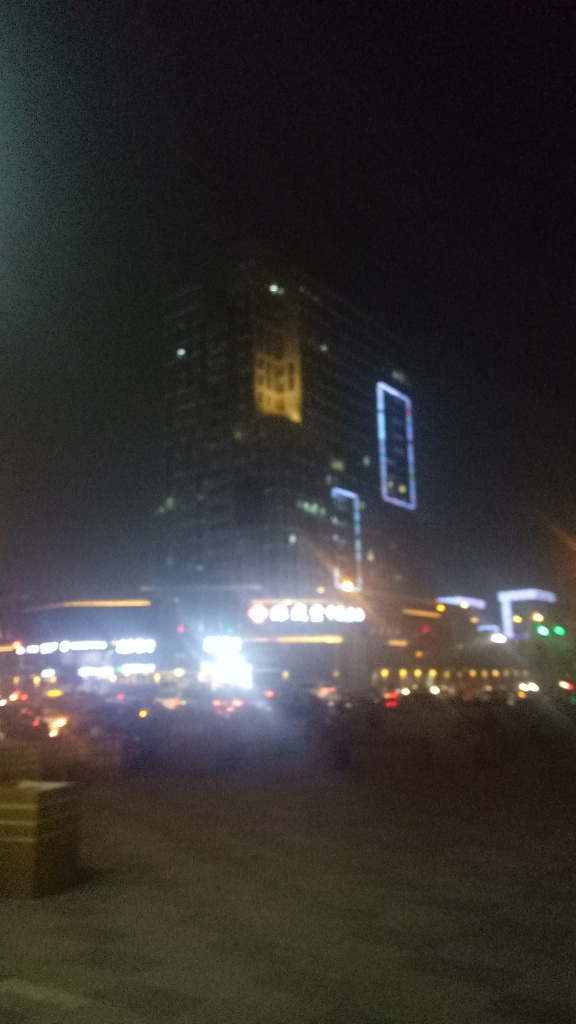Can you describe the environment portrayed in this image? The image appears to capture an urban nighttime scene, illuminated by artificial lights from buildings and street lamps. The environment is likely part of a cityscape, with high-rise buildings that feature neon signage or decorative lighting. The blurriness of the image suggests movement or a low-quality camera capture. Despite the poor image quality, the presence of lights and possibly the silhouettes of vehicles and faint figures indicate a bustling urban life. 